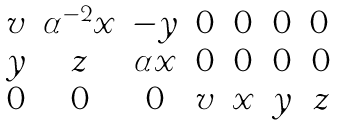Convert formula to latex. <formula><loc_0><loc_0><loc_500><loc_500>\begin{matrix} v & \alpha ^ { - 2 } x & - y & 0 & 0 & 0 & 0 \, \\ y & z & \alpha x & 0 & 0 & 0 & 0 \\ 0 & 0 & 0 & v & x & y & z \end{matrix}</formula> 